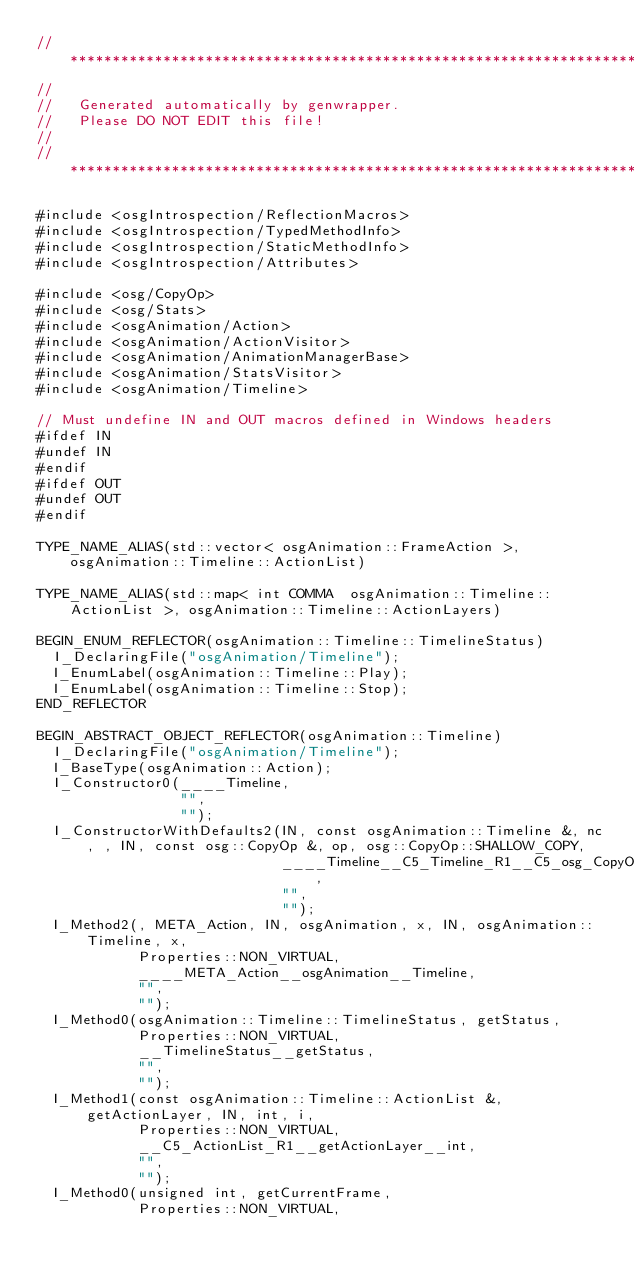<code> <loc_0><loc_0><loc_500><loc_500><_C++_>// ***************************************************************************
//
//   Generated automatically by genwrapper.
//   Please DO NOT EDIT this file!
//
// ***************************************************************************

#include <osgIntrospection/ReflectionMacros>
#include <osgIntrospection/TypedMethodInfo>
#include <osgIntrospection/StaticMethodInfo>
#include <osgIntrospection/Attributes>

#include <osg/CopyOp>
#include <osg/Stats>
#include <osgAnimation/Action>
#include <osgAnimation/ActionVisitor>
#include <osgAnimation/AnimationManagerBase>
#include <osgAnimation/StatsVisitor>
#include <osgAnimation/Timeline>

// Must undefine IN and OUT macros defined in Windows headers
#ifdef IN
#undef IN
#endif
#ifdef OUT
#undef OUT
#endif

TYPE_NAME_ALIAS(std::vector< osgAnimation::FrameAction >, osgAnimation::Timeline::ActionList)

TYPE_NAME_ALIAS(std::map< int COMMA  osgAnimation::Timeline::ActionList >, osgAnimation::Timeline::ActionLayers)

BEGIN_ENUM_REFLECTOR(osgAnimation::Timeline::TimelineStatus)
	I_DeclaringFile("osgAnimation/Timeline");
	I_EnumLabel(osgAnimation::Timeline::Play);
	I_EnumLabel(osgAnimation::Timeline::Stop);
END_REFLECTOR

BEGIN_ABSTRACT_OBJECT_REFLECTOR(osgAnimation::Timeline)
	I_DeclaringFile("osgAnimation/Timeline");
	I_BaseType(osgAnimation::Action);
	I_Constructor0(____Timeline,
	               "",
	               "");
	I_ConstructorWithDefaults2(IN, const osgAnimation::Timeline &, nc, , IN, const osg::CopyOp &, op, osg::CopyOp::SHALLOW_COPY,
	                           ____Timeline__C5_Timeline_R1__C5_osg_CopyOp_R1,
	                           "",
	                           "");
	I_Method2(, META_Action, IN, osgAnimation, x, IN, osgAnimation::Timeline, x,
	          Properties::NON_VIRTUAL,
	          ____META_Action__osgAnimation__Timeline,
	          "",
	          "");
	I_Method0(osgAnimation::Timeline::TimelineStatus, getStatus,
	          Properties::NON_VIRTUAL,
	          __TimelineStatus__getStatus,
	          "",
	          "");
	I_Method1(const osgAnimation::Timeline::ActionList &, getActionLayer, IN, int, i,
	          Properties::NON_VIRTUAL,
	          __C5_ActionList_R1__getActionLayer__int,
	          "",
	          "");
	I_Method0(unsigned int, getCurrentFrame,
	          Properties::NON_VIRTUAL,</code> 